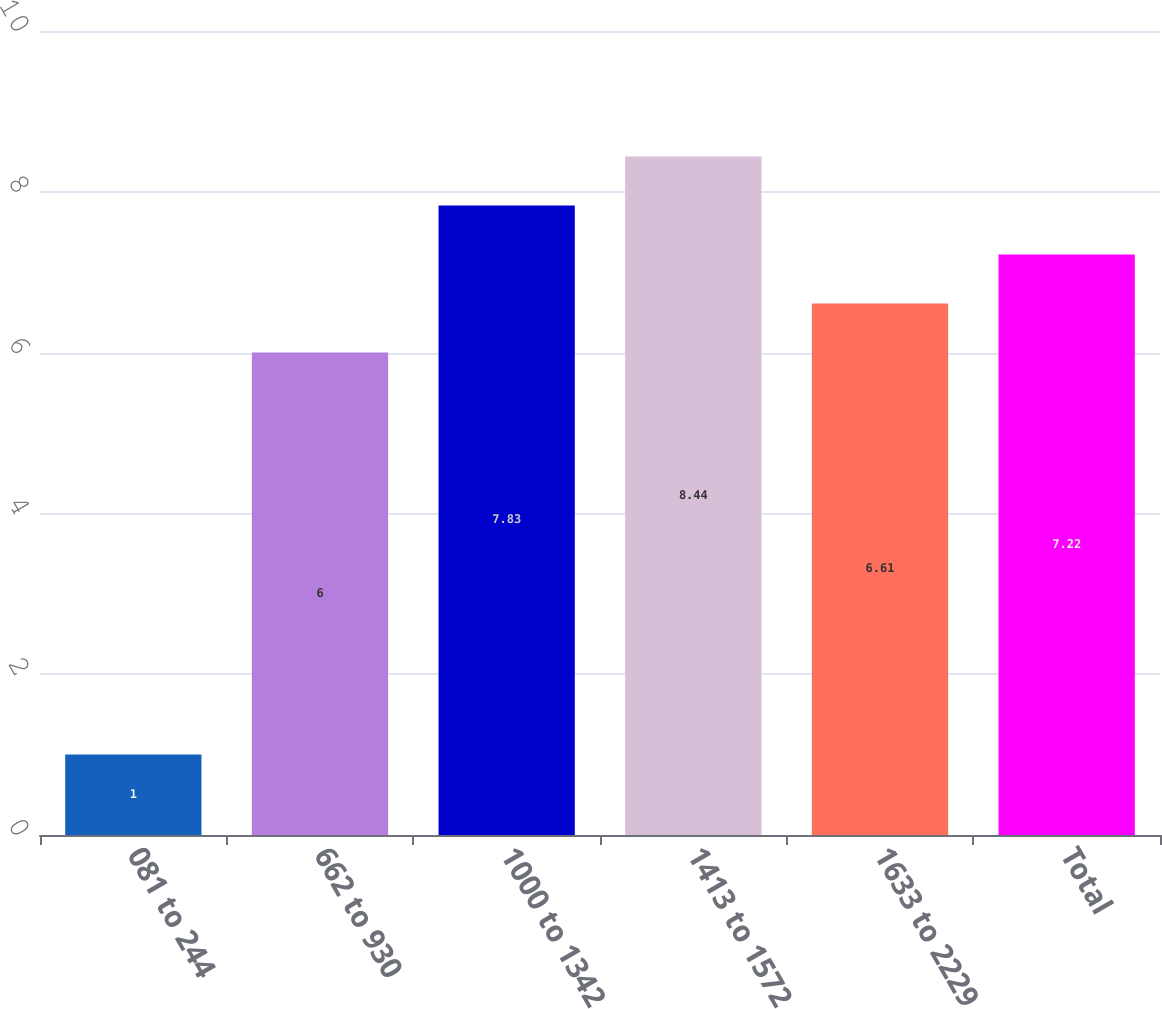Convert chart to OTSL. <chart><loc_0><loc_0><loc_500><loc_500><bar_chart><fcel>081 to 244<fcel>662 to 930<fcel>1000 to 1342<fcel>1413 to 1572<fcel>1633 to 2229<fcel>Total<nl><fcel>1<fcel>6<fcel>7.83<fcel>8.44<fcel>6.61<fcel>7.22<nl></chart> 